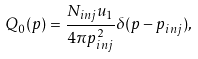<formula> <loc_0><loc_0><loc_500><loc_500>Q _ { 0 } ( p ) = \frac { N _ { i n j } u _ { 1 } } { 4 \pi p _ { i n j } ^ { 2 } } \delta ( p - p _ { i n j } ) ,</formula> 